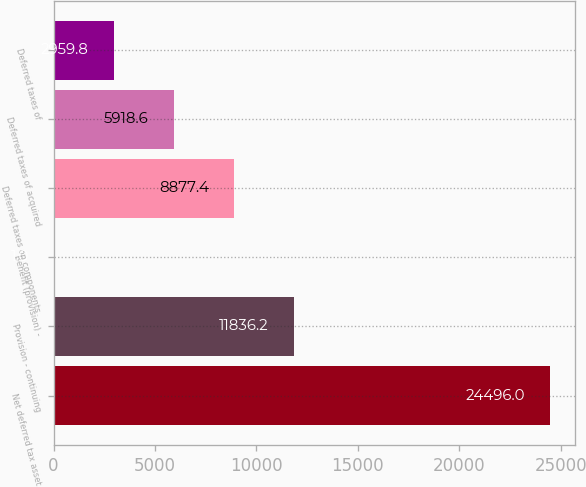Convert chart to OTSL. <chart><loc_0><loc_0><loc_500><loc_500><bar_chart><fcel>Net deferred tax asset<fcel>Provision - continuing<fcel>Benefit (provision) -<fcel>Deferred taxes on components<fcel>Deferred taxes of acquired<fcel>Deferred taxes of<nl><fcel>24496<fcel>11836.2<fcel>1<fcel>8877.4<fcel>5918.6<fcel>2959.8<nl></chart> 